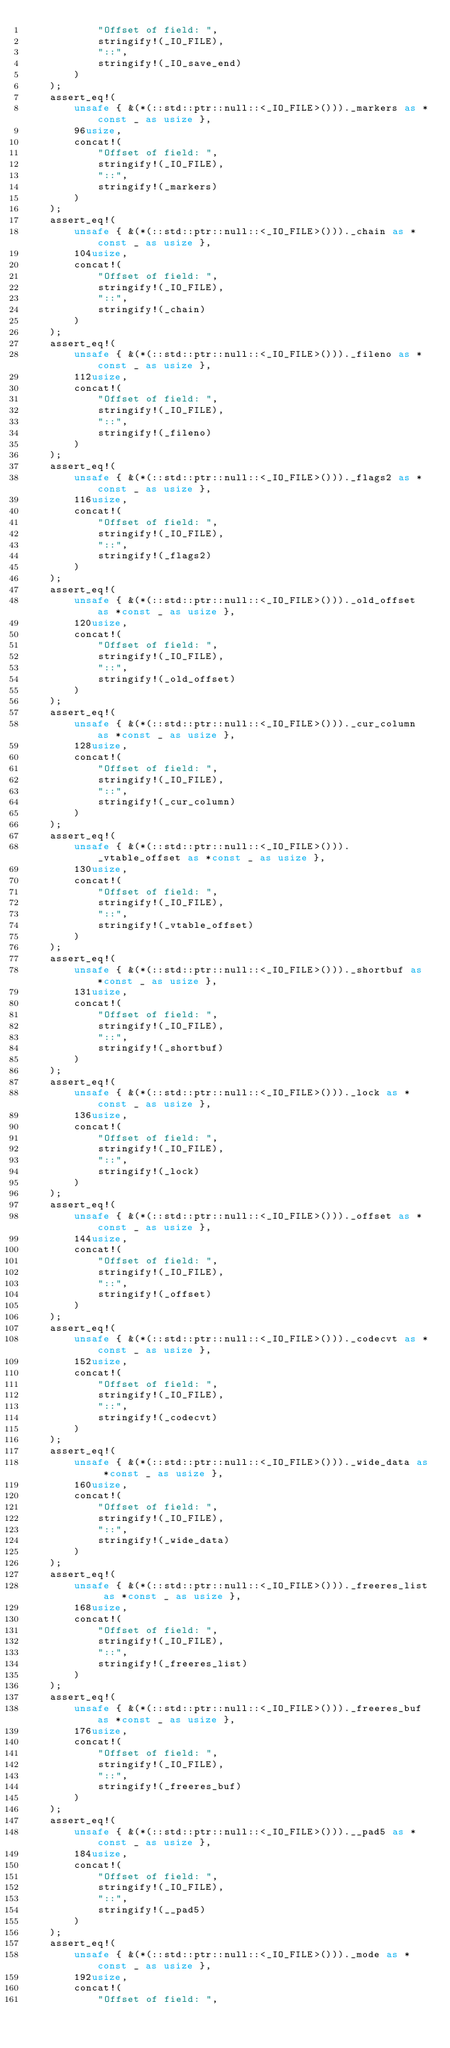<code> <loc_0><loc_0><loc_500><loc_500><_Rust_>            "Offset of field: ",
            stringify!(_IO_FILE),
            "::",
            stringify!(_IO_save_end)
        )
    );
    assert_eq!(
        unsafe { &(*(::std::ptr::null::<_IO_FILE>()))._markers as *const _ as usize },
        96usize,
        concat!(
            "Offset of field: ",
            stringify!(_IO_FILE),
            "::",
            stringify!(_markers)
        )
    );
    assert_eq!(
        unsafe { &(*(::std::ptr::null::<_IO_FILE>()))._chain as *const _ as usize },
        104usize,
        concat!(
            "Offset of field: ",
            stringify!(_IO_FILE),
            "::",
            stringify!(_chain)
        )
    );
    assert_eq!(
        unsafe { &(*(::std::ptr::null::<_IO_FILE>()))._fileno as *const _ as usize },
        112usize,
        concat!(
            "Offset of field: ",
            stringify!(_IO_FILE),
            "::",
            stringify!(_fileno)
        )
    );
    assert_eq!(
        unsafe { &(*(::std::ptr::null::<_IO_FILE>()))._flags2 as *const _ as usize },
        116usize,
        concat!(
            "Offset of field: ",
            stringify!(_IO_FILE),
            "::",
            stringify!(_flags2)
        )
    );
    assert_eq!(
        unsafe { &(*(::std::ptr::null::<_IO_FILE>()))._old_offset as *const _ as usize },
        120usize,
        concat!(
            "Offset of field: ",
            stringify!(_IO_FILE),
            "::",
            stringify!(_old_offset)
        )
    );
    assert_eq!(
        unsafe { &(*(::std::ptr::null::<_IO_FILE>()))._cur_column as *const _ as usize },
        128usize,
        concat!(
            "Offset of field: ",
            stringify!(_IO_FILE),
            "::",
            stringify!(_cur_column)
        )
    );
    assert_eq!(
        unsafe { &(*(::std::ptr::null::<_IO_FILE>()))._vtable_offset as *const _ as usize },
        130usize,
        concat!(
            "Offset of field: ",
            stringify!(_IO_FILE),
            "::",
            stringify!(_vtable_offset)
        )
    );
    assert_eq!(
        unsafe { &(*(::std::ptr::null::<_IO_FILE>()))._shortbuf as *const _ as usize },
        131usize,
        concat!(
            "Offset of field: ",
            stringify!(_IO_FILE),
            "::",
            stringify!(_shortbuf)
        )
    );
    assert_eq!(
        unsafe { &(*(::std::ptr::null::<_IO_FILE>()))._lock as *const _ as usize },
        136usize,
        concat!(
            "Offset of field: ",
            stringify!(_IO_FILE),
            "::",
            stringify!(_lock)
        )
    );
    assert_eq!(
        unsafe { &(*(::std::ptr::null::<_IO_FILE>()))._offset as *const _ as usize },
        144usize,
        concat!(
            "Offset of field: ",
            stringify!(_IO_FILE),
            "::",
            stringify!(_offset)
        )
    );
    assert_eq!(
        unsafe { &(*(::std::ptr::null::<_IO_FILE>()))._codecvt as *const _ as usize },
        152usize,
        concat!(
            "Offset of field: ",
            stringify!(_IO_FILE),
            "::",
            stringify!(_codecvt)
        )
    );
    assert_eq!(
        unsafe { &(*(::std::ptr::null::<_IO_FILE>()))._wide_data as *const _ as usize },
        160usize,
        concat!(
            "Offset of field: ",
            stringify!(_IO_FILE),
            "::",
            stringify!(_wide_data)
        )
    );
    assert_eq!(
        unsafe { &(*(::std::ptr::null::<_IO_FILE>()))._freeres_list as *const _ as usize },
        168usize,
        concat!(
            "Offset of field: ",
            stringify!(_IO_FILE),
            "::",
            stringify!(_freeres_list)
        )
    );
    assert_eq!(
        unsafe { &(*(::std::ptr::null::<_IO_FILE>()))._freeres_buf as *const _ as usize },
        176usize,
        concat!(
            "Offset of field: ",
            stringify!(_IO_FILE),
            "::",
            stringify!(_freeres_buf)
        )
    );
    assert_eq!(
        unsafe { &(*(::std::ptr::null::<_IO_FILE>())).__pad5 as *const _ as usize },
        184usize,
        concat!(
            "Offset of field: ",
            stringify!(_IO_FILE),
            "::",
            stringify!(__pad5)
        )
    );
    assert_eq!(
        unsafe { &(*(::std::ptr::null::<_IO_FILE>()))._mode as *const _ as usize },
        192usize,
        concat!(
            "Offset of field: ",</code> 